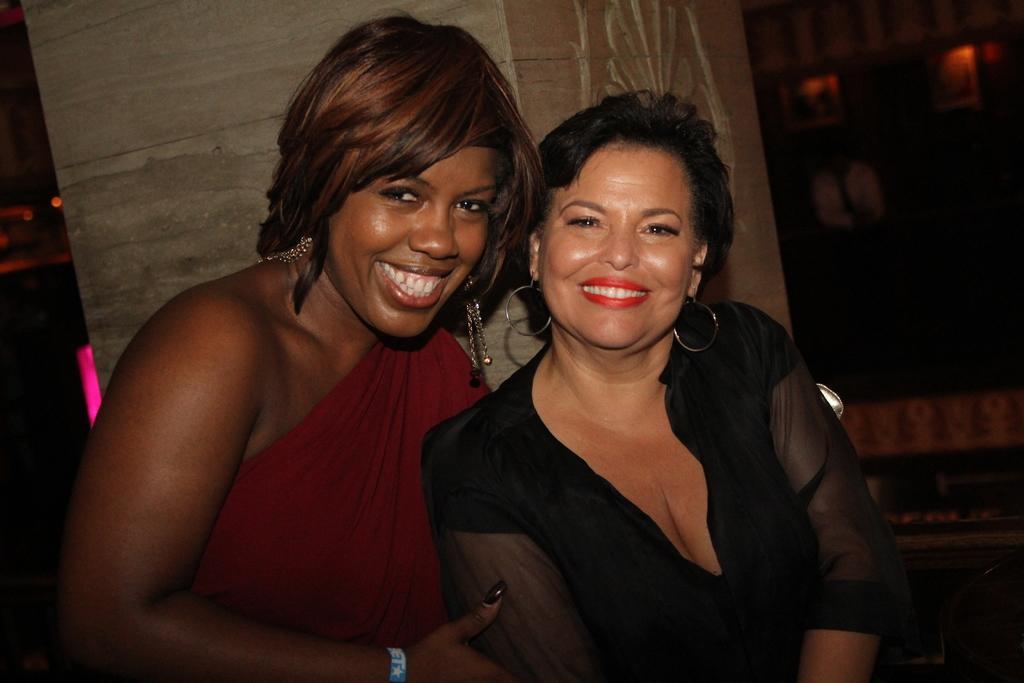Can you describe this image briefly? In this image we can see women sitting and smiling. In the background there is a pillar. 